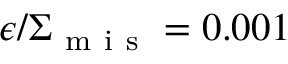Convert formula to latex. <formula><loc_0><loc_0><loc_500><loc_500>\epsilon / \Sigma _ { m i s } = 0 . 0 0 1</formula> 